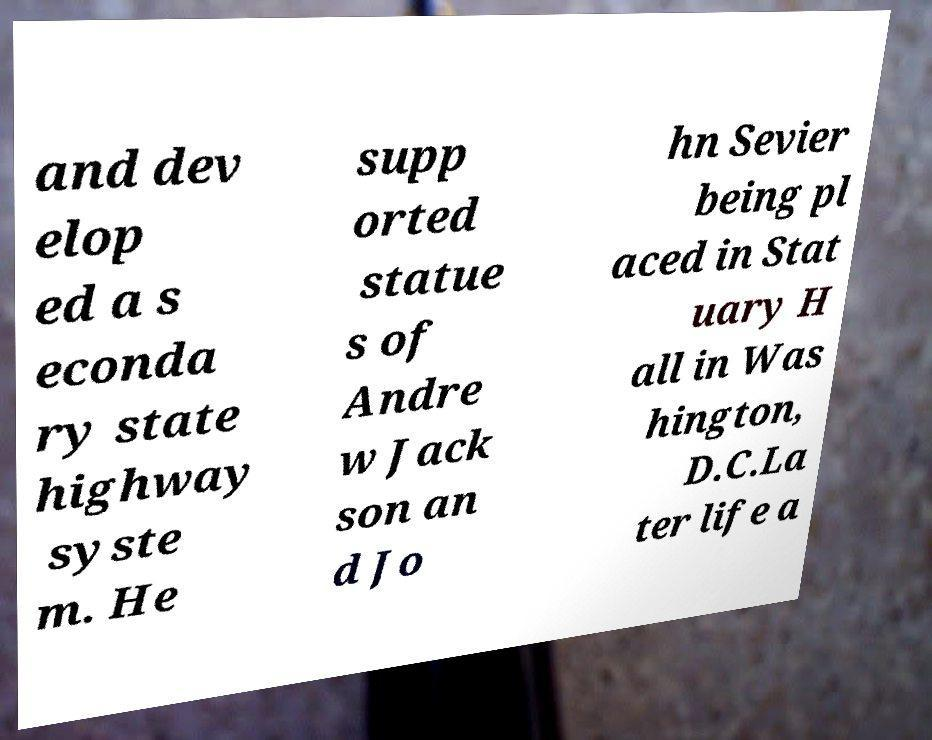There's text embedded in this image that I need extracted. Can you transcribe it verbatim? and dev elop ed a s econda ry state highway syste m. He supp orted statue s of Andre w Jack son an d Jo hn Sevier being pl aced in Stat uary H all in Was hington, D.C.La ter life a 